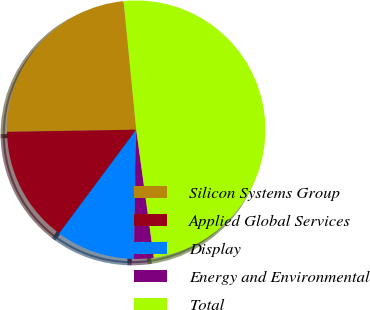Convert chart. <chart><loc_0><loc_0><loc_500><loc_500><pie_chart><fcel>Silicon Systems Group<fcel>Applied Global Services<fcel>Display<fcel>Energy and Environmental<fcel>Total<nl><fcel>23.7%<fcel>14.57%<fcel>9.88%<fcel>2.47%<fcel>49.38%<nl></chart> 